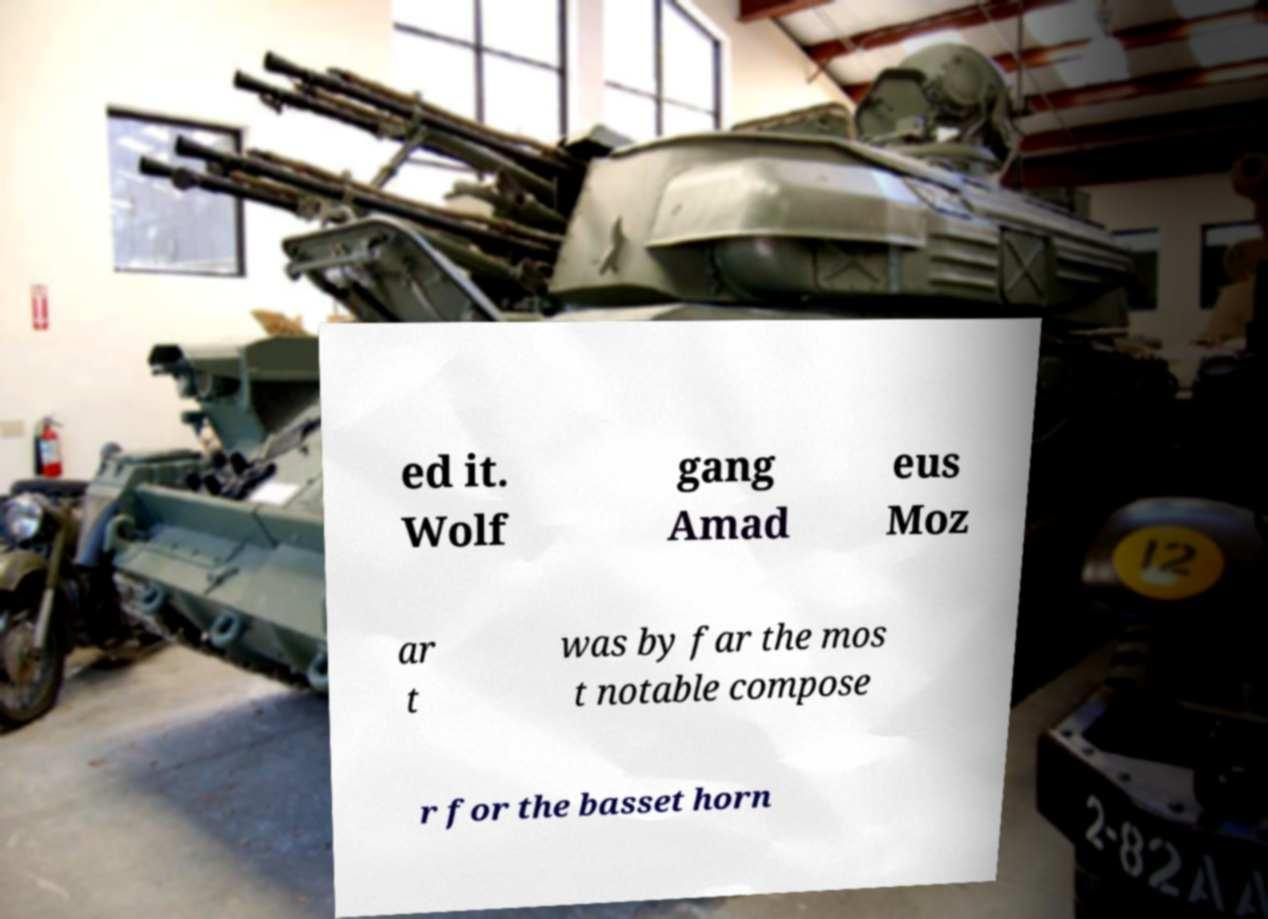Could you extract and type out the text from this image? ed it. Wolf gang Amad eus Moz ar t was by far the mos t notable compose r for the basset horn 